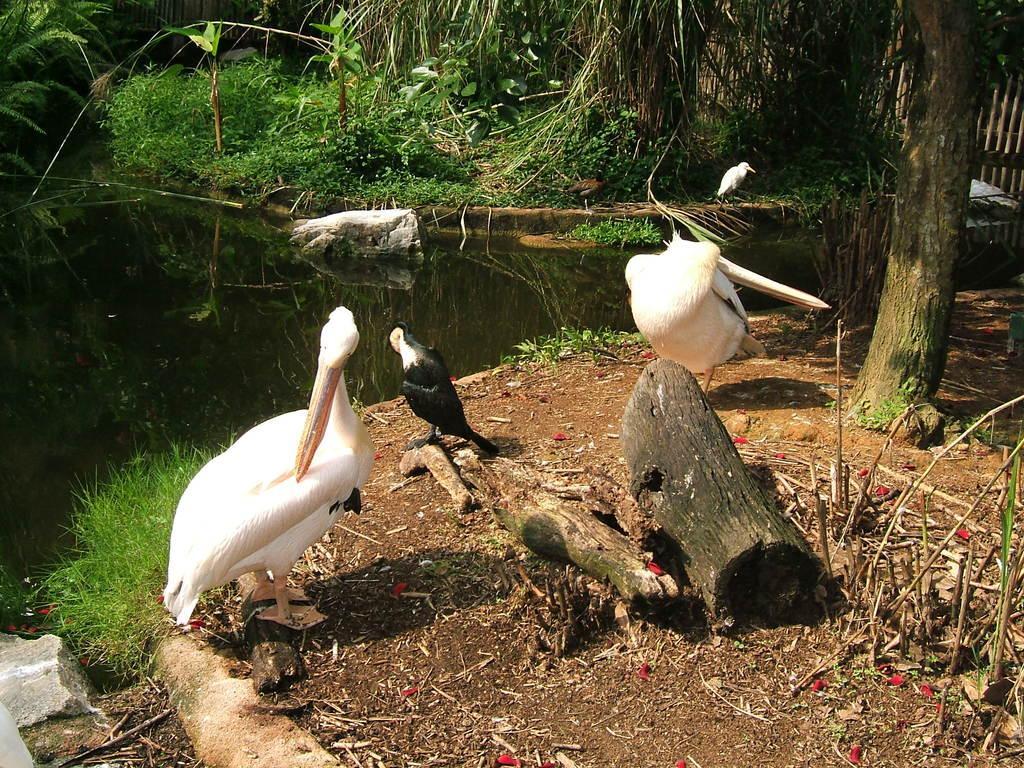Please provide a concise description of this image. In this picture there are ducks in the center of the image and there is greenery at the top side of the image. 